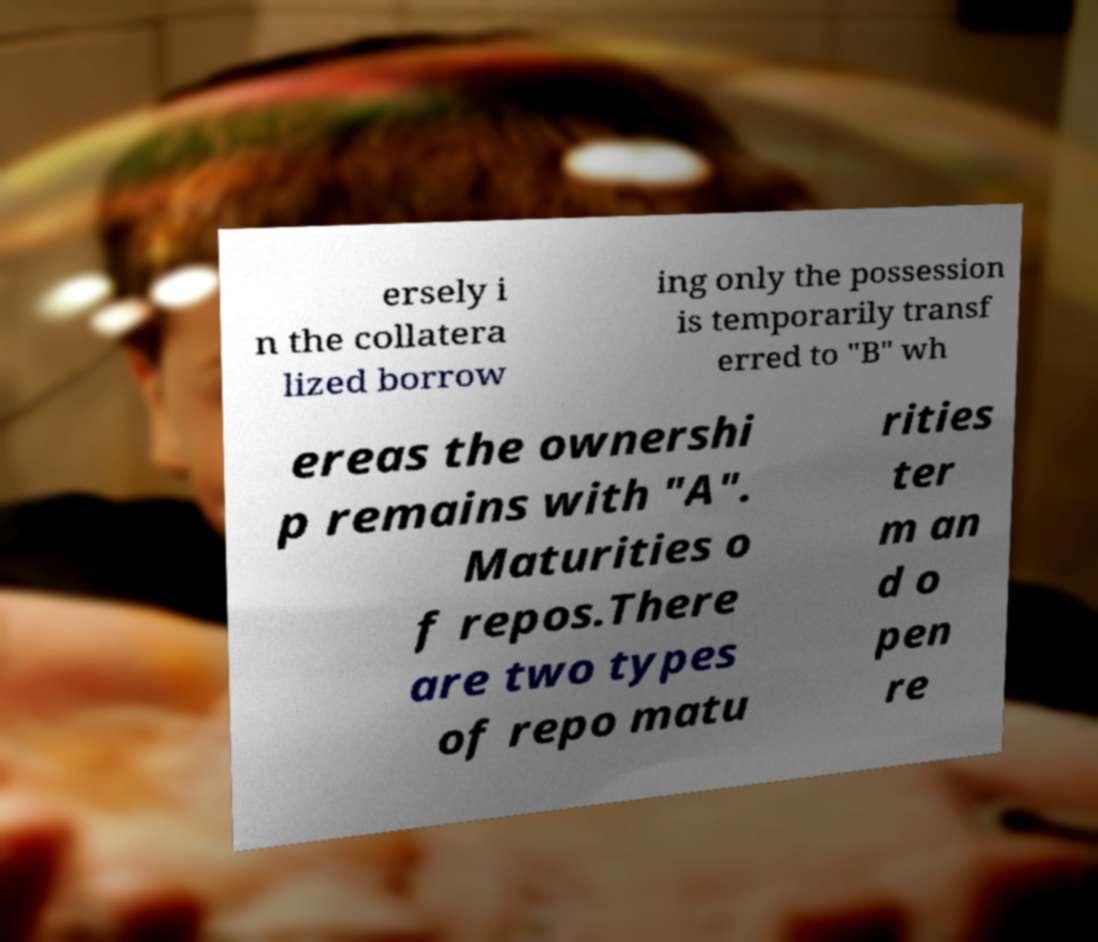For documentation purposes, I need the text within this image transcribed. Could you provide that? ersely i n the collatera lized borrow ing only the possession is temporarily transf erred to "B" wh ereas the ownershi p remains with "A". Maturities o f repos.There are two types of repo matu rities ter m an d o pen re 